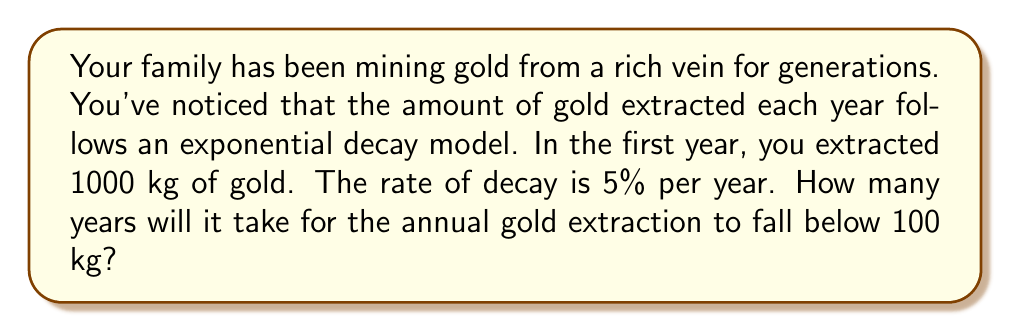Teach me how to tackle this problem. To solve this problem, we need to use the exponential decay formula and solve for time. Let's break it down step-by-step:

1) The exponential decay formula is:

   $$A(t) = A_0 e^{-kt}$$

   Where:
   $A(t)$ is the amount at time $t$
   $A_0$ is the initial amount
   $k$ is the decay constant
   $t$ is time

2) We're given:
   $A_0 = 1000$ kg (initial amount)
   Rate of decay = 5% = 0.05 per year
   $A(t) = 100$ kg (we want to find when it reaches this value)

3) The decay constant $k$ is the rate of decay, so $k = 0.05$

4) Plugging these into our formula:

   $$100 = 1000 e^{-0.05t}$$

5) Divide both sides by 1000:

   $$0.1 = e^{-0.05t}$$

6) Take the natural log of both sides:

   $$\ln(0.1) = -0.05t$$

7) Solve for $t$:

   $$t = \frac{\ln(0.1)}{-0.05} = \frac{-2.30259}{-0.05} \approx 46.05178$$

8) Since we can't have a fractional year in this context, we round up to the next whole year.
Answer: It will take 47 years for the annual gold extraction to fall below 100 kg. 